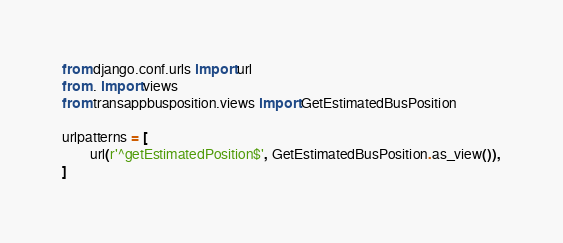Convert code to text. <code><loc_0><loc_0><loc_500><loc_500><_Python_>from django.conf.urls import url
from . import views
from transappbusposition.views import GetEstimatedBusPosition

urlpatterns = [
        url(r'^getEstimatedPosition$', GetEstimatedBusPosition.as_view()),
]
</code> 